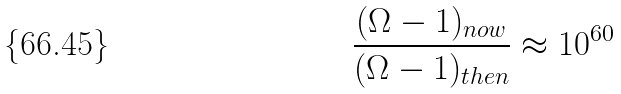<formula> <loc_0><loc_0><loc_500><loc_500>\frac { ( \Omega - 1 ) _ { n o w } } { ( \Omega - 1 ) _ { t h e n } } \approx 1 0 ^ { 6 0 }</formula> 